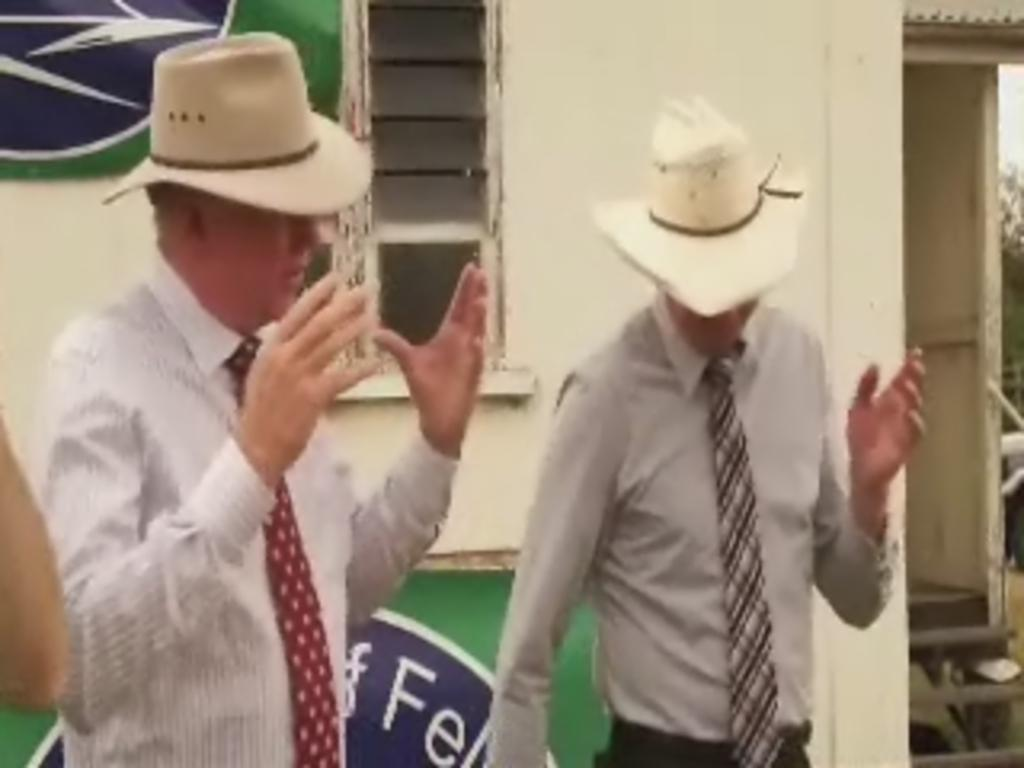How many men are in the image? There are two men standing in the image. What are the men wearing on their heads? The men are wearing hats. What type of clothing are the men wearing on their upper bodies? The men are wearing shirts. What type of accessory are the men wearing around their necks? The men are wearing ties. What can be seen in the background of the image? There is a house in the background of the image. What features can be identified on the house? The house has a window and a door. What type of wool can be seen in the image? There is no wool present in the image. What kind of club is the men attending in the image? There is no club or gathering depicted in the image; it simply shows two men standing together. 